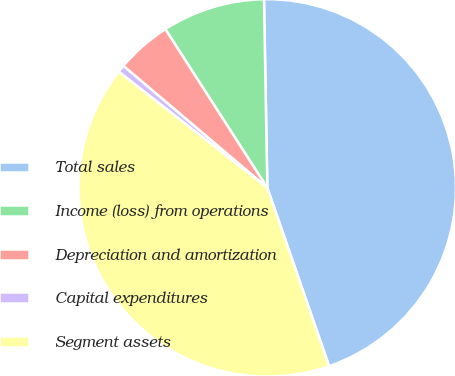Convert chart. <chart><loc_0><loc_0><loc_500><loc_500><pie_chart><fcel>Total sales<fcel>Income (loss) from operations<fcel>Depreciation and amortization<fcel>Capital expenditures<fcel>Segment assets<nl><fcel>44.97%<fcel>8.81%<fcel>4.72%<fcel>0.63%<fcel>40.87%<nl></chart> 